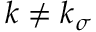Convert formula to latex. <formula><loc_0><loc_0><loc_500><loc_500>k \neq k _ { \sigma }</formula> 